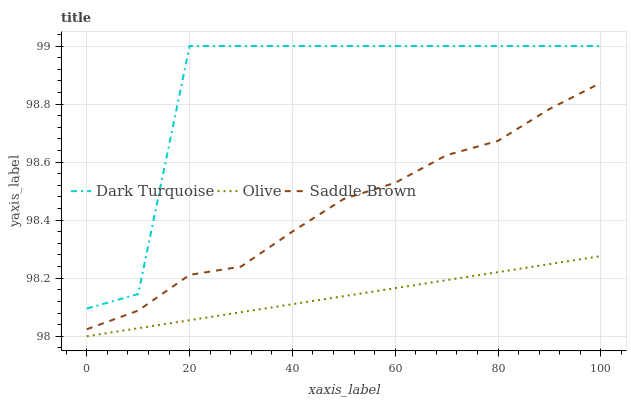Does Olive have the minimum area under the curve?
Answer yes or no. Yes. Does Dark Turquoise have the maximum area under the curve?
Answer yes or no. Yes. Does Saddle Brown have the minimum area under the curve?
Answer yes or no. No. Does Saddle Brown have the maximum area under the curve?
Answer yes or no. No. Is Olive the smoothest?
Answer yes or no. Yes. Is Dark Turquoise the roughest?
Answer yes or no. Yes. Is Saddle Brown the smoothest?
Answer yes or no. No. Is Saddle Brown the roughest?
Answer yes or no. No. Does Olive have the lowest value?
Answer yes or no. Yes. Does Saddle Brown have the lowest value?
Answer yes or no. No. Does Dark Turquoise have the highest value?
Answer yes or no. Yes. Does Saddle Brown have the highest value?
Answer yes or no. No. Is Olive less than Dark Turquoise?
Answer yes or no. Yes. Is Dark Turquoise greater than Saddle Brown?
Answer yes or no. Yes. Does Olive intersect Dark Turquoise?
Answer yes or no. No. 